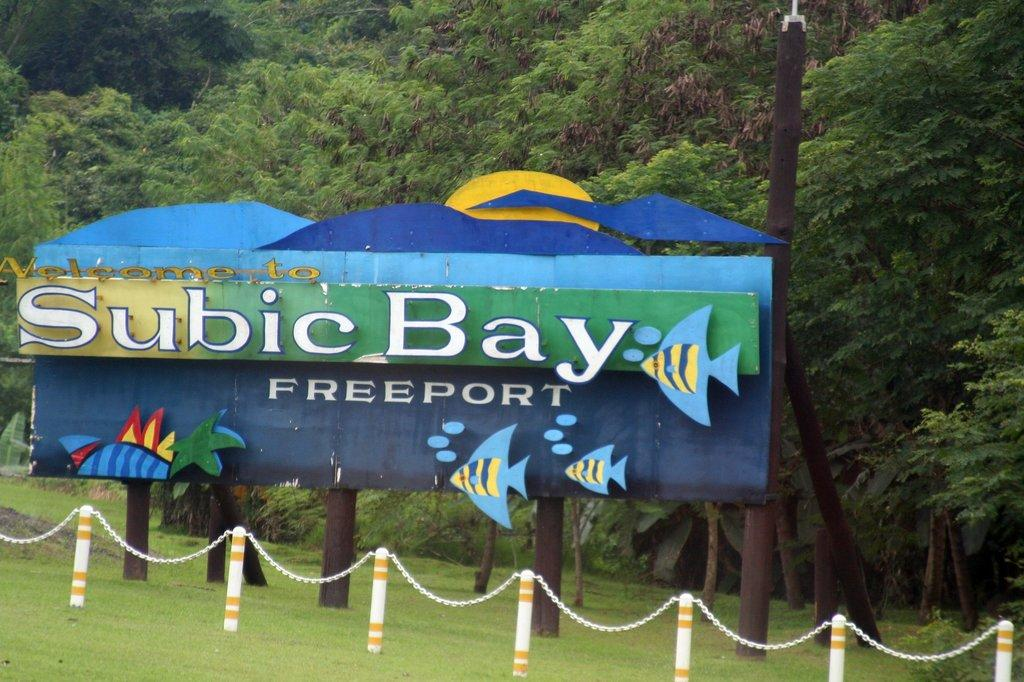What type of vegetation is present on the ground in the image? There is grass on the ground in the image. What structure can be seen in the center of the image? There is a fence in the center of the image. What is written on the board in the image? There is a board with text in the image. What can be seen in the background of the image? There are trees in the background of the image. Can you tell me how many rats are sitting on the board in the image? There are no rats present in the image; the board has text on it. What type of insurance is being advertised on the board in the image? There is no insurance information on the board in the image; it only contains text. 